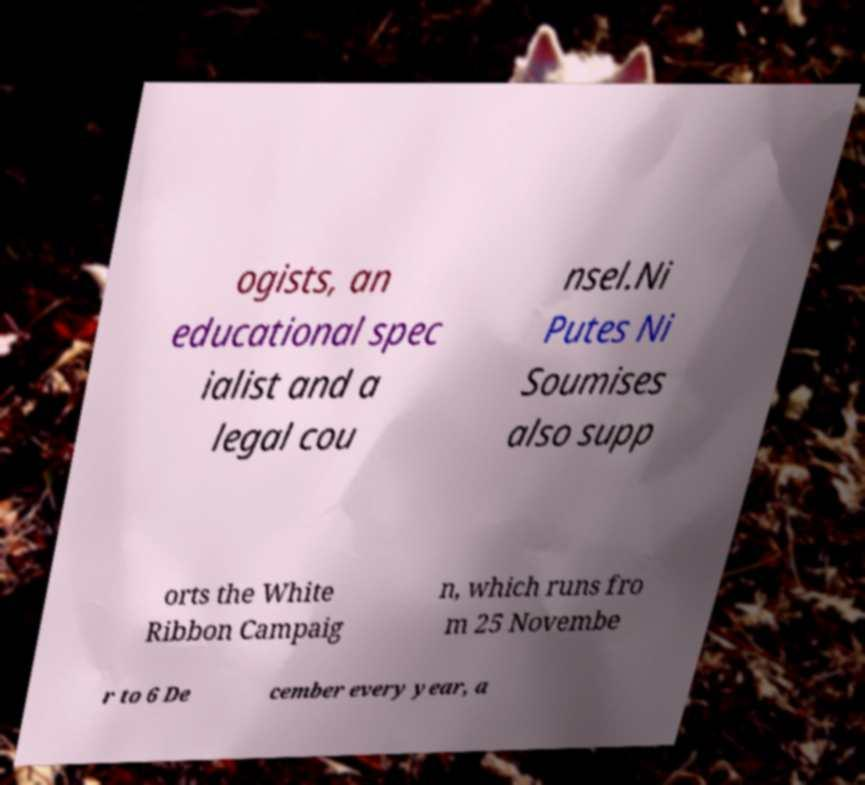Please read and relay the text visible in this image. What does it say? ogists, an educational spec ialist and a legal cou nsel.Ni Putes Ni Soumises also supp orts the White Ribbon Campaig n, which runs fro m 25 Novembe r to 6 De cember every year, a 